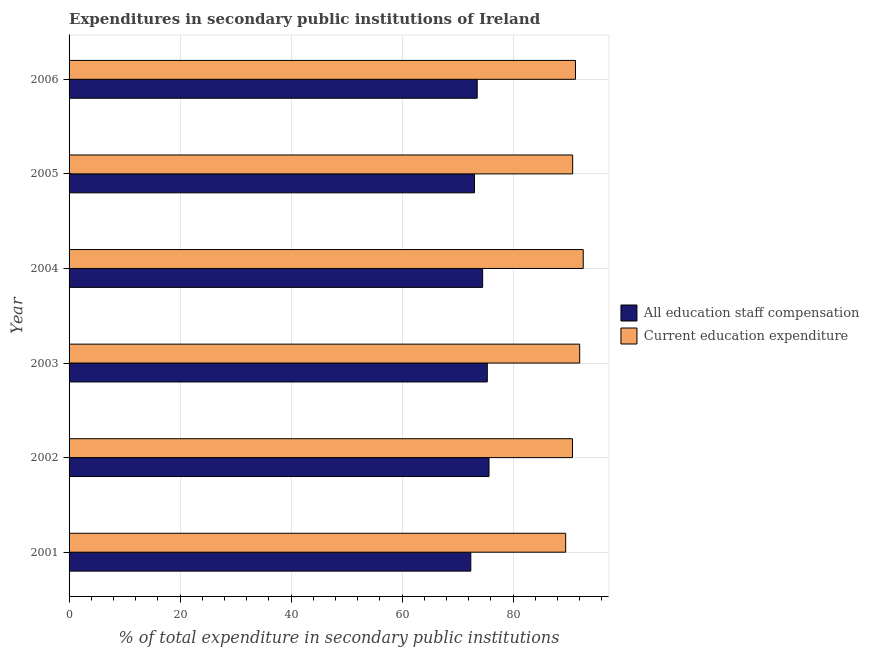How many different coloured bars are there?
Ensure brevity in your answer.  2. How many groups of bars are there?
Your response must be concise. 6. Are the number of bars on each tick of the Y-axis equal?
Make the answer very short. Yes. In how many cases, is the number of bars for a given year not equal to the number of legend labels?
Your answer should be compact. 0. What is the expenditure in staff compensation in 2001?
Offer a terse response. 72.4. Across all years, what is the maximum expenditure in staff compensation?
Your answer should be very brief. 75.68. Across all years, what is the minimum expenditure in education?
Give a very brief answer. 89.49. What is the total expenditure in education in the graph?
Provide a short and direct response. 546.91. What is the difference between the expenditure in education in 2003 and that in 2006?
Give a very brief answer. 0.76. What is the difference between the expenditure in staff compensation in 2002 and the expenditure in education in 2006?
Give a very brief answer. -15.58. What is the average expenditure in education per year?
Make the answer very short. 91.15. In the year 2001, what is the difference between the expenditure in staff compensation and expenditure in education?
Keep it short and to the point. -17.1. In how many years, is the expenditure in education greater than 52 %?
Provide a succinct answer. 6. Is the expenditure in education in 2002 less than that in 2005?
Make the answer very short. Yes. Is the difference between the expenditure in staff compensation in 2005 and 2006 greater than the difference between the expenditure in education in 2005 and 2006?
Ensure brevity in your answer.  Yes. What is the difference between the highest and the second highest expenditure in staff compensation?
Make the answer very short. 0.31. What is the difference between the highest and the lowest expenditure in education?
Your answer should be compact. 3.16. What does the 2nd bar from the top in 2001 represents?
Keep it short and to the point. All education staff compensation. What does the 1st bar from the bottom in 2006 represents?
Provide a short and direct response. All education staff compensation. How many bars are there?
Offer a terse response. 12. Are all the bars in the graph horizontal?
Give a very brief answer. Yes. What is the difference between two consecutive major ticks on the X-axis?
Your response must be concise. 20. Where does the legend appear in the graph?
Keep it short and to the point. Center right. What is the title of the graph?
Provide a short and direct response. Expenditures in secondary public institutions of Ireland. What is the label or title of the X-axis?
Make the answer very short. % of total expenditure in secondary public institutions. What is the % of total expenditure in secondary public institutions in All education staff compensation in 2001?
Your answer should be compact. 72.4. What is the % of total expenditure in secondary public institutions of Current education expenditure in 2001?
Provide a succinct answer. 89.49. What is the % of total expenditure in secondary public institutions in All education staff compensation in 2002?
Make the answer very short. 75.68. What is the % of total expenditure in secondary public institutions in Current education expenditure in 2002?
Ensure brevity in your answer.  90.72. What is the % of total expenditure in secondary public institutions of All education staff compensation in 2003?
Keep it short and to the point. 75.37. What is the % of total expenditure in secondary public institutions of Current education expenditure in 2003?
Offer a very short reply. 92.02. What is the % of total expenditure in secondary public institutions of All education staff compensation in 2004?
Your answer should be compact. 74.53. What is the % of total expenditure in secondary public institutions of Current education expenditure in 2004?
Provide a short and direct response. 92.66. What is the % of total expenditure in secondary public institutions in All education staff compensation in 2005?
Provide a short and direct response. 73.06. What is the % of total expenditure in secondary public institutions of Current education expenditure in 2005?
Make the answer very short. 90.75. What is the % of total expenditure in secondary public institutions in All education staff compensation in 2006?
Make the answer very short. 73.55. What is the % of total expenditure in secondary public institutions of Current education expenditure in 2006?
Your answer should be compact. 91.26. Across all years, what is the maximum % of total expenditure in secondary public institutions in All education staff compensation?
Provide a succinct answer. 75.68. Across all years, what is the maximum % of total expenditure in secondary public institutions in Current education expenditure?
Offer a very short reply. 92.66. Across all years, what is the minimum % of total expenditure in secondary public institutions in All education staff compensation?
Your answer should be compact. 72.4. Across all years, what is the minimum % of total expenditure in secondary public institutions in Current education expenditure?
Your answer should be compact. 89.49. What is the total % of total expenditure in secondary public institutions in All education staff compensation in the graph?
Offer a terse response. 444.58. What is the total % of total expenditure in secondary public institutions in Current education expenditure in the graph?
Your response must be concise. 546.91. What is the difference between the % of total expenditure in secondary public institutions in All education staff compensation in 2001 and that in 2002?
Your answer should be compact. -3.28. What is the difference between the % of total expenditure in secondary public institutions in Current education expenditure in 2001 and that in 2002?
Your answer should be compact. -1.23. What is the difference between the % of total expenditure in secondary public institutions in All education staff compensation in 2001 and that in 2003?
Make the answer very short. -2.97. What is the difference between the % of total expenditure in secondary public institutions in Current education expenditure in 2001 and that in 2003?
Keep it short and to the point. -2.53. What is the difference between the % of total expenditure in secondary public institutions in All education staff compensation in 2001 and that in 2004?
Make the answer very short. -2.14. What is the difference between the % of total expenditure in secondary public institutions of Current education expenditure in 2001 and that in 2004?
Give a very brief answer. -3.16. What is the difference between the % of total expenditure in secondary public institutions in All education staff compensation in 2001 and that in 2005?
Ensure brevity in your answer.  -0.66. What is the difference between the % of total expenditure in secondary public institutions in Current education expenditure in 2001 and that in 2005?
Provide a succinct answer. -1.26. What is the difference between the % of total expenditure in secondary public institutions of All education staff compensation in 2001 and that in 2006?
Your response must be concise. -1.15. What is the difference between the % of total expenditure in secondary public institutions in Current education expenditure in 2001 and that in 2006?
Provide a succinct answer. -1.77. What is the difference between the % of total expenditure in secondary public institutions of All education staff compensation in 2002 and that in 2003?
Keep it short and to the point. 0.31. What is the difference between the % of total expenditure in secondary public institutions of Current education expenditure in 2002 and that in 2003?
Give a very brief answer. -1.3. What is the difference between the % of total expenditure in secondary public institutions of All education staff compensation in 2002 and that in 2004?
Provide a short and direct response. 1.15. What is the difference between the % of total expenditure in secondary public institutions in Current education expenditure in 2002 and that in 2004?
Provide a succinct answer. -1.94. What is the difference between the % of total expenditure in secondary public institutions in All education staff compensation in 2002 and that in 2005?
Make the answer very short. 2.62. What is the difference between the % of total expenditure in secondary public institutions in Current education expenditure in 2002 and that in 2005?
Offer a terse response. -0.03. What is the difference between the % of total expenditure in secondary public institutions of All education staff compensation in 2002 and that in 2006?
Your answer should be compact. 2.13. What is the difference between the % of total expenditure in secondary public institutions in Current education expenditure in 2002 and that in 2006?
Make the answer very short. -0.54. What is the difference between the % of total expenditure in secondary public institutions of All education staff compensation in 2003 and that in 2004?
Your answer should be compact. 0.84. What is the difference between the % of total expenditure in secondary public institutions in Current education expenditure in 2003 and that in 2004?
Provide a succinct answer. -0.64. What is the difference between the % of total expenditure in secondary public institutions of All education staff compensation in 2003 and that in 2005?
Provide a succinct answer. 2.31. What is the difference between the % of total expenditure in secondary public institutions of Current education expenditure in 2003 and that in 2005?
Offer a very short reply. 1.27. What is the difference between the % of total expenditure in secondary public institutions of All education staff compensation in 2003 and that in 2006?
Ensure brevity in your answer.  1.82. What is the difference between the % of total expenditure in secondary public institutions of Current education expenditure in 2003 and that in 2006?
Provide a succinct answer. 0.76. What is the difference between the % of total expenditure in secondary public institutions in All education staff compensation in 2004 and that in 2005?
Ensure brevity in your answer.  1.47. What is the difference between the % of total expenditure in secondary public institutions of Current education expenditure in 2004 and that in 2005?
Provide a short and direct response. 1.91. What is the difference between the % of total expenditure in secondary public institutions in All education staff compensation in 2004 and that in 2006?
Keep it short and to the point. 0.98. What is the difference between the % of total expenditure in secondary public institutions in Current education expenditure in 2004 and that in 2006?
Your answer should be compact. 1.4. What is the difference between the % of total expenditure in secondary public institutions of All education staff compensation in 2005 and that in 2006?
Offer a very short reply. -0.49. What is the difference between the % of total expenditure in secondary public institutions of Current education expenditure in 2005 and that in 2006?
Keep it short and to the point. -0.51. What is the difference between the % of total expenditure in secondary public institutions of All education staff compensation in 2001 and the % of total expenditure in secondary public institutions of Current education expenditure in 2002?
Your response must be concise. -18.33. What is the difference between the % of total expenditure in secondary public institutions of All education staff compensation in 2001 and the % of total expenditure in secondary public institutions of Current education expenditure in 2003?
Ensure brevity in your answer.  -19.62. What is the difference between the % of total expenditure in secondary public institutions of All education staff compensation in 2001 and the % of total expenditure in secondary public institutions of Current education expenditure in 2004?
Your answer should be compact. -20.26. What is the difference between the % of total expenditure in secondary public institutions in All education staff compensation in 2001 and the % of total expenditure in secondary public institutions in Current education expenditure in 2005?
Your answer should be compact. -18.36. What is the difference between the % of total expenditure in secondary public institutions of All education staff compensation in 2001 and the % of total expenditure in secondary public institutions of Current education expenditure in 2006?
Make the answer very short. -18.86. What is the difference between the % of total expenditure in secondary public institutions in All education staff compensation in 2002 and the % of total expenditure in secondary public institutions in Current education expenditure in 2003?
Offer a very short reply. -16.34. What is the difference between the % of total expenditure in secondary public institutions in All education staff compensation in 2002 and the % of total expenditure in secondary public institutions in Current education expenditure in 2004?
Keep it short and to the point. -16.98. What is the difference between the % of total expenditure in secondary public institutions in All education staff compensation in 2002 and the % of total expenditure in secondary public institutions in Current education expenditure in 2005?
Provide a short and direct response. -15.08. What is the difference between the % of total expenditure in secondary public institutions in All education staff compensation in 2002 and the % of total expenditure in secondary public institutions in Current education expenditure in 2006?
Your response must be concise. -15.58. What is the difference between the % of total expenditure in secondary public institutions of All education staff compensation in 2003 and the % of total expenditure in secondary public institutions of Current education expenditure in 2004?
Your answer should be very brief. -17.29. What is the difference between the % of total expenditure in secondary public institutions in All education staff compensation in 2003 and the % of total expenditure in secondary public institutions in Current education expenditure in 2005?
Make the answer very short. -15.38. What is the difference between the % of total expenditure in secondary public institutions in All education staff compensation in 2003 and the % of total expenditure in secondary public institutions in Current education expenditure in 2006?
Keep it short and to the point. -15.89. What is the difference between the % of total expenditure in secondary public institutions of All education staff compensation in 2004 and the % of total expenditure in secondary public institutions of Current education expenditure in 2005?
Your answer should be compact. -16.22. What is the difference between the % of total expenditure in secondary public institutions in All education staff compensation in 2004 and the % of total expenditure in secondary public institutions in Current education expenditure in 2006?
Keep it short and to the point. -16.73. What is the difference between the % of total expenditure in secondary public institutions in All education staff compensation in 2005 and the % of total expenditure in secondary public institutions in Current education expenditure in 2006?
Offer a terse response. -18.2. What is the average % of total expenditure in secondary public institutions of All education staff compensation per year?
Your answer should be very brief. 74.1. What is the average % of total expenditure in secondary public institutions in Current education expenditure per year?
Give a very brief answer. 91.15. In the year 2001, what is the difference between the % of total expenditure in secondary public institutions in All education staff compensation and % of total expenditure in secondary public institutions in Current education expenditure?
Offer a very short reply. -17.1. In the year 2002, what is the difference between the % of total expenditure in secondary public institutions in All education staff compensation and % of total expenditure in secondary public institutions in Current education expenditure?
Your answer should be compact. -15.04. In the year 2003, what is the difference between the % of total expenditure in secondary public institutions in All education staff compensation and % of total expenditure in secondary public institutions in Current education expenditure?
Your answer should be very brief. -16.65. In the year 2004, what is the difference between the % of total expenditure in secondary public institutions in All education staff compensation and % of total expenditure in secondary public institutions in Current education expenditure?
Ensure brevity in your answer.  -18.13. In the year 2005, what is the difference between the % of total expenditure in secondary public institutions of All education staff compensation and % of total expenditure in secondary public institutions of Current education expenditure?
Provide a short and direct response. -17.69. In the year 2006, what is the difference between the % of total expenditure in secondary public institutions of All education staff compensation and % of total expenditure in secondary public institutions of Current education expenditure?
Provide a short and direct response. -17.71. What is the ratio of the % of total expenditure in secondary public institutions of All education staff compensation in 2001 to that in 2002?
Keep it short and to the point. 0.96. What is the ratio of the % of total expenditure in secondary public institutions of Current education expenditure in 2001 to that in 2002?
Ensure brevity in your answer.  0.99. What is the ratio of the % of total expenditure in secondary public institutions of All education staff compensation in 2001 to that in 2003?
Your answer should be compact. 0.96. What is the ratio of the % of total expenditure in secondary public institutions in Current education expenditure in 2001 to that in 2003?
Provide a succinct answer. 0.97. What is the ratio of the % of total expenditure in secondary public institutions in All education staff compensation in 2001 to that in 2004?
Ensure brevity in your answer.  0.97. What is the ratio of the % of total expenditure in secondary public institutions of Current education expenditure in 2001 to that in 2004?
Give a very brief answer. 0.97. What is the ratio of the % of total expenditure in secondary public institutions of All education staff compensation in 2001 to that in 2005?
Your answer should be very brief. 0.99. What is the ratio of the % of total expenditure in secondary public institutions of Current education expenditure in 2001 to that in 2005?
Your answer should be very brief. 0.99. What is the ratio of the % of total expenditure in secondary public institutions in All education staff compensation in 2001 to that in 2006?
Provide a short and direct response. 0.98. What is the ratio of the % of total expenditure in secondary public institutions in Current education expenditure in 2001 to that in 2006?
Your response must be concise. 0.98. What is the ratio of the % of total expenditure in secondary public institutions of All education staff compensation in 2002 to that in 2003?
Keep it short and to the point. 1. What is the ratio of the % of total expenditure in secondary public institutions in Current education expenditure in 2002 to that in 2003?
Your answer should be compact. 0.99. What is the ratio of the % of total expenditure in secondary public institutions of All education staff compensation in 2002 to that in 2004?
Your answer should be very brief. 1.02. What is the ratio of the % of total expenditure in secondary public institutions of Current education expenditure in 2002 to that in 2004?
Offer a very short reply. 0.98. What is the ratio of the % of total expenditure in secondary public institutions in All education staff compensation in 2002 to that in 2005?
Keep it short and to the point. 1.04. What is the ratio of the % of total expenditure in secondary public institutions in Current education expenditure in 2002 to that in 2005?
Offer a very short reply. 1. What is the ratio of the % of total expenditure in secondary public institutions in All education staff compensation in 2002 to that in 2006?
Provide a succinct answer. 1.03. What is the ratio of the % of total expenditure in secondary public institutions in All education staff compensation in 2003 to that in 2004?
Your answer should be compact. 1.01. What is the ratio of the % of total expenditure in secondary public institutions in Current education expenditure in 2003 to that in 2004?
Your response must be concise. 0.99. What is the ratio of the % of total expenditure in secondary public institutions of All education staff compensation in 2003 to that in 2005?
Your answer should be very brief. 1.03. What is the ratio of the % of total expenditure in secondary public institutions of Current education expenditure in 2003 to that in 2005?
Your response must be concise. 1.01. What is the ratio of the % of total expenditure in secondary public institutions in All education staff compensation in 2003 to that in 2006?
Ensure brevity in your answer.  1.02. What is the ratio of the % of total expenditure in secondary public institutions in Current education expenditure in 2003 to that in 2006?
Provide a short and direct response. 1.01. What is the ratio of the % of total expenditure in secondary public institutions of All education staff compensation in 2004 to that in 2005?
Provide a short and direct response. 1.02. What is the ratio of the % of total expenditure in secondary public institutions in Current education expenditure in 2004 to that in 2005?
Offer a terse response. 1.02. What is the ratio of the % of total expenditure in secondary public institutions of All education staff compensation in 2004 to that in 2006?
Your answer should be very brief. 1.01. What is the ratio of the % of total expenditure in secondary public institutions in Current education expenditure in 2004 to that in 2006?
Your answer should be compact. 1.02. What is the ratio of the % of total expenditure in secondary public institutions in All education staff compensation in 2005 to that in 2006?
Offer a very short reply. 0.99. What is the difference between the highest and the second highest % of total expenditure in secondary public institutions in All education staff compensation?
Your answer should be very brief. 0.31. What is the difference between the highest and the second highest % of total expenditure in secondary public institutions in Current education expenditure?
Ensure brevity in your answer.  0.64. What is the difference between the highest and the lowest % of total expenditure in secondary public institutions in All education staff compensation?
Ensure brevity in your answer.  3.28. What is the difference between the highest and the lowest % of total expenditure in secondary public institutions in Current education expenditure?
Your response must be concise. 3.16. 